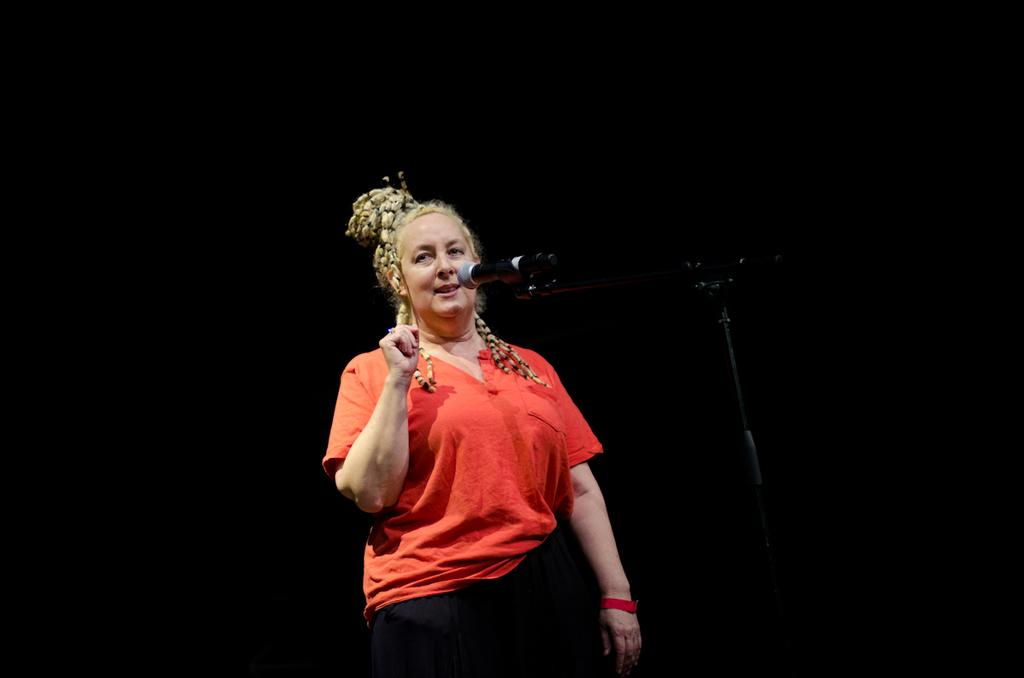What is the main subject of the image? There is a woman standing in the image. What object is visible near the woman? There is a microphone in the image. What structure can be seen in the image? There is a stand in the image. What can be said about the background of the image? The background of the image is completely dark. How many trucks can be seen through the window in the image? There is no window or trucks present in the image. 